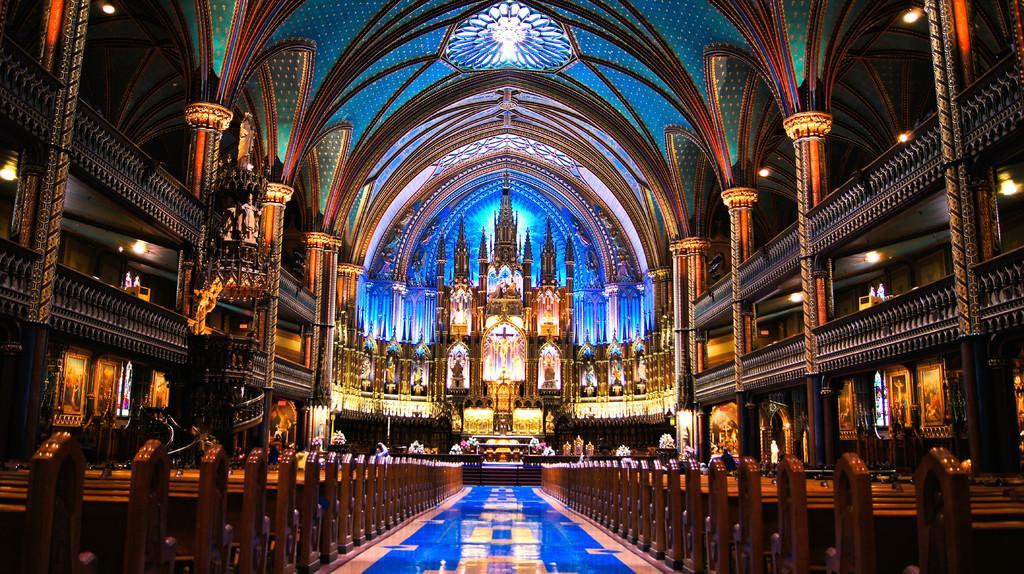In one or two sentences, can you explain what this image depicts? This image is taken inside the church. In the church we can see the benches on either side of the way. In the middle there is a cross symbol. At the top there is ceiling with the lights. On the left side there are pillars and floors one above the other. There is wall on either side of the church. To the wall there are photo frames. 